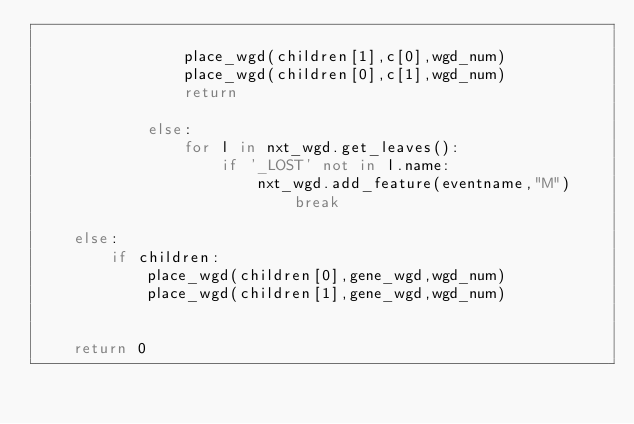<code> <loc_0><loc_0><loc_500><loc_500><_Python_>                                
                place_wgd(children[1],c[0],wgd_num)
                place_wgd(children[0],c[1],wgd_num)
                return
                            
            else:
                for l in nxt_wgd.get_leaves():
                    if '_LOST' not in l.name:
                        nxt_wgd.add_feature(eventname,"M")
                            break
        
    else:
        if children:
            place_wgd(children[0],gene_wgd,wgd_num)
            place_wgd(children[1],gene_wgd,wgd_num)
    
    
    return 0
</code> 